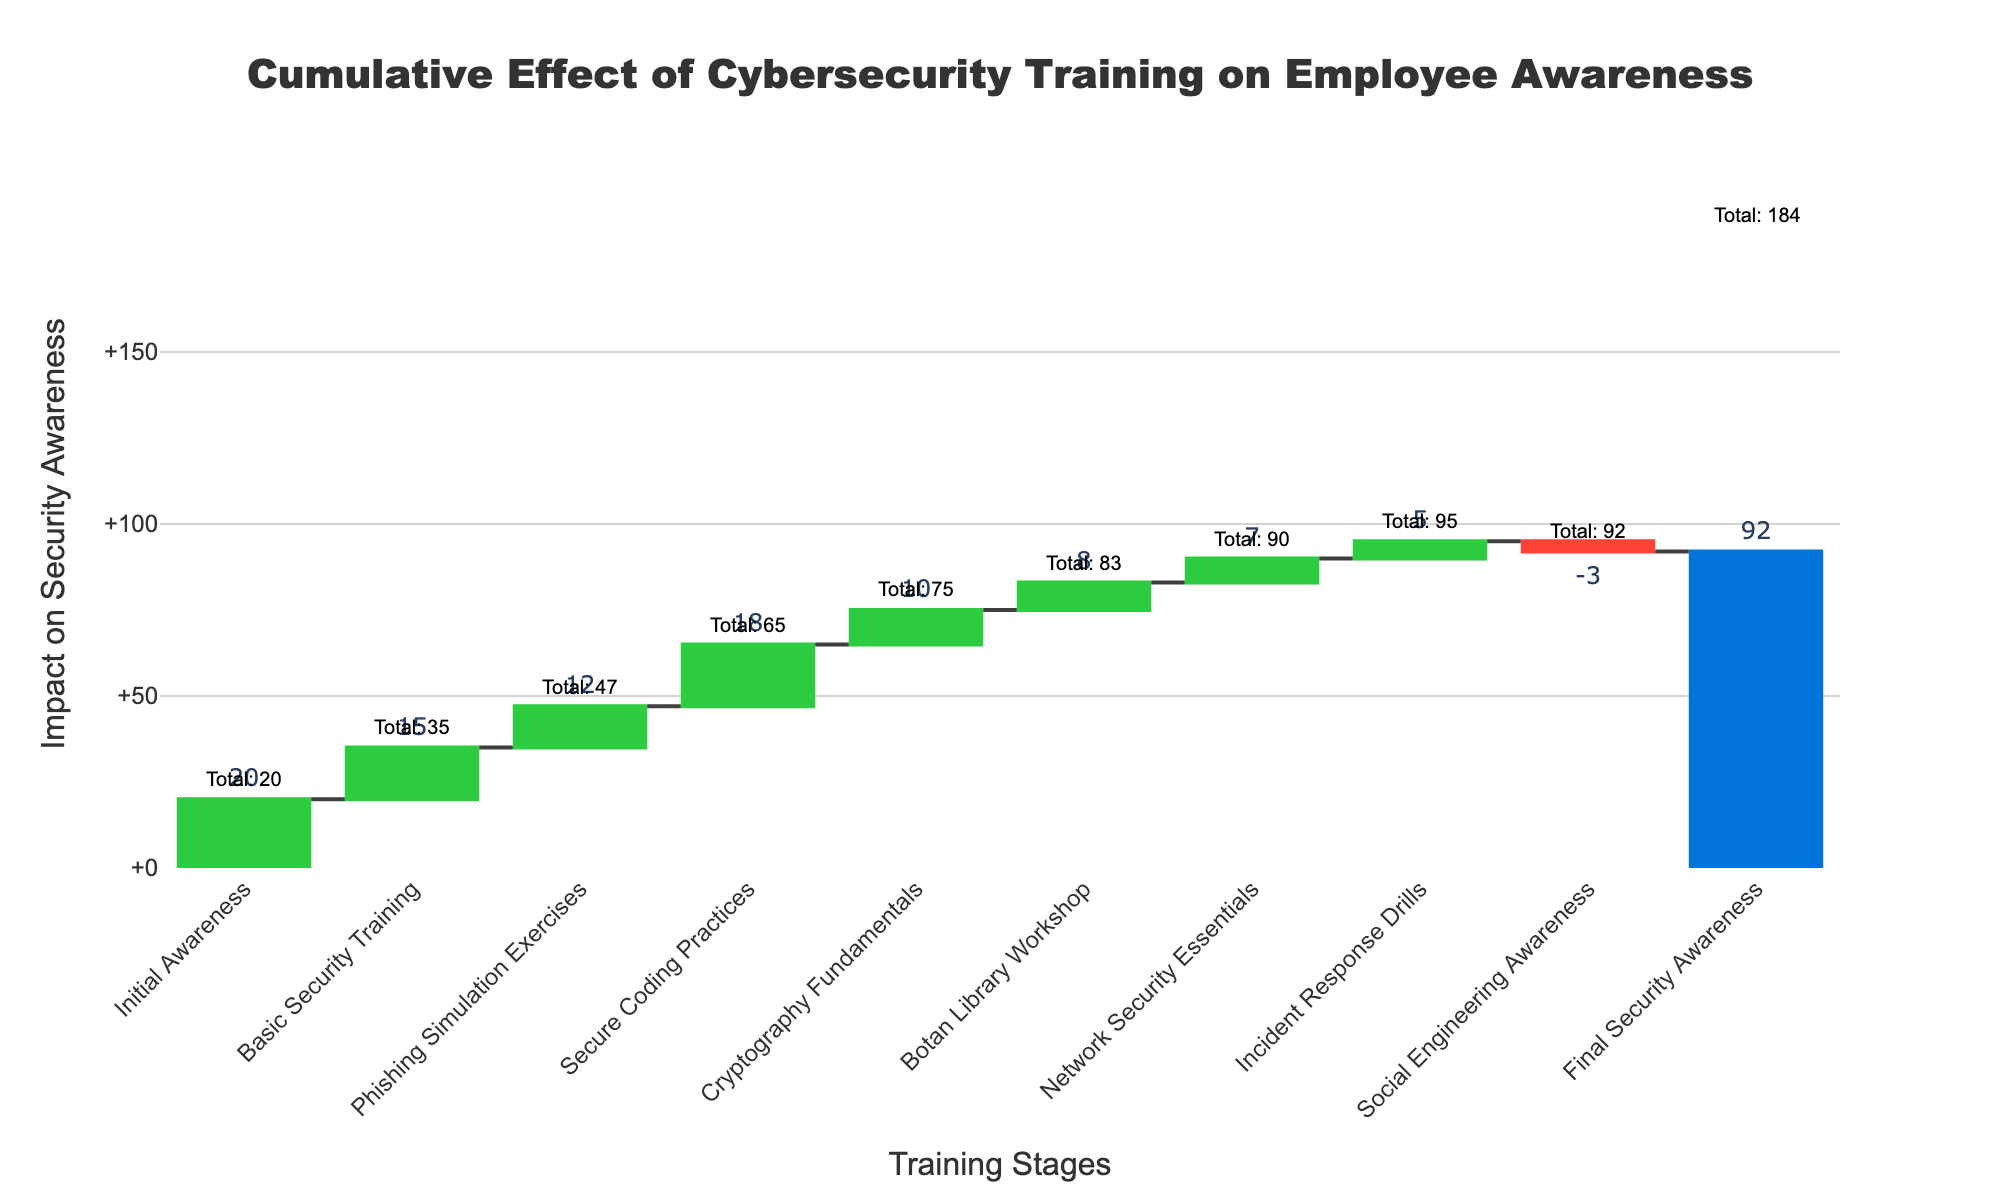What's the title of the chart? The title of the chart is typically displayed at the top and it reads "Cumulative Effect of Cybersecurity Training on Employee Awareness".
Answer: Cumulative Effect of Cybersecurity Training on Employee Awareness How many training stages are shown in the chart? The chart lists each stage of training along the x-axis. Counting them will give the total number of training stages.
Answer: 9 What is the initial value of employee security awareness? The initial value is the first bar in the chart, labeled "Initial Awareness". Observing this bar reveals its value.
Answer: 20 Which training stage had a negative impact on security awareness, and what is the value? Look for the bar that is colored differently, indicating a decrease, and find its label and value.
Answer: Social Engineering Awareness, -3 What is the sum of values for "Basic Security Training" and "Phishing Simulation Exercises"? Add the values associated with these two training stages: 15 (Basic Security Training) + 12 (Phishing Simulation Exercises).
Answer: 27 By how much did the "Botan Library Workshop" improve security awareness? Identify the value corresponding to the "Botan Library Workshop" stage.
Answer: 8 Which training stage contributed the most to security awareness? Compare the values of all the positive contributions and determine the largest one.
Answer: Secure Coding Practices What is the total cumulative effect after the "Incident Response Drills"? Find the cumulative value annotated next to the "Incident Response Drills" stage in the chart.
Answer: 95 By how much did the security awareness increase from the "Initial Awareness" to the "Final Security Awareness"? Subtract the initial value (20) from the final value (92) to find the total increase.
Answer: 72 How does the effect of "Phishing Simulation Exercises" compare to "Network Security Essentials"? Compare the values associated with the two stages: 12 (Phishing Simulation Exercises) and 7 (Network Security Essentials).
Answer: Phishing Simulation Exercises is higher by 5 